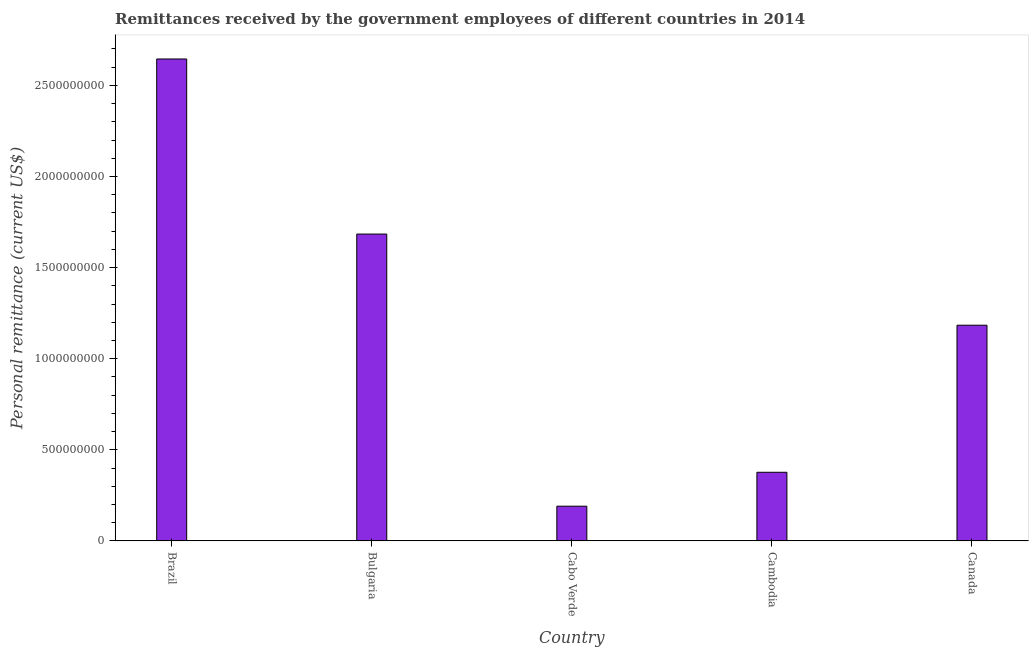Does the graph contain grids?
Your answer should be compact. No. What is the title of the graph?
Give a very brief answer. Remittances received by the government employees of different countries in 2014. What is the label or title of the X-axis?
Offer a very short reply. Country. What is the label or title of the Y-axis?
Your answer should be compact. Personal remittance (current US$). What is the personal remittances in Bulgaria?
Keep it short and to the point. 1.68e+09. Across all countries, what is the maximum personal remittances?
Provide a succinct answer. 2.65e+09. Across all countries, what is the minimum personal remittances?
Provide a succinct answer. 1.91e+08. In which country was the personal remittances maximum?
Your response must be concise. Brazil. In which country was the personal remittances minimum?
Provide a succinct answer. Cabo Verde. What is the sum of the personal remittances?
Make the answer very short. 6.08e+09. What is the difference between the personal remittances in Brazil and Bulgaria?
Offer a very short reply. 9.61e+08. What is the average personal remittances per country?
Provide a short and direct response. 1.22e+09. What is the median personal remittances?
Offer a very short reply. 1.18e+09. In how many countries, is the personal remittances greater than 2200000000 US$?
Offer a terse response. 1. What is the ratio of the personal remittances in Cabo Verde to that in Canada?
Your answer should be very brief. 0.16. Is the personal remittances in Bulgaria less than that in Cambodia?
Provide a succinct answer. No. What is the difference between the highest and the second highest personal remittances?
Your response must be concise. 9.61e+08. Is the sum of the personal remittances in Brazil and Cabo Verde greater than the maximum personal remittances across all countries?
Your answer should be compact. Yes. What is the difference between the highest and the lowest personal remittances?
Your response must be concise. 2.45e+09. Are all the bars in the graph horizontal?
Provide a short and direct response. No. What is the difference between two consecutive major ticks on the Y-axis?
Your answer should be very brief. 5.00e+08. What is the Personal remittance (current US$) of Brazil?
Offer a very short reply. 2.65e+09. What is the Personal remittance (current US$) of Bulgaria?
Your answer should be compact. 1.68e+09. What is the Personal remittance (current US$) of Cabo Verde?
Your response must be concise. 1.91e+08. What is the Personal remittance (current US$) in Cambodia?
Ensure brevity in your answer.  3.77e+08. What is the Personal remittance (current US$) in Canada?
Your answer should be very brief. 1.18e+09. What is the difference between the Personal remittance (current US$) in Brazil and Bulgaria?
Offer a terse response. 9.61e+08. What is the difference between the Personal remittance (current US$) in Brazil and Cabo Verde?
Your answer should be compact. 2.45e+09. What is the difference between the Personal remittance (current US$) in Brazil and Cambodia?
Your answer should be compact. 2.27e+09. What is the difference between the Personal remittance (current US$) in Brazil and Canada?
Your answer should be compact. 1.46e+09. What is the difference between the Personal remittance (current US$) in Bulgaria and Cabo Verde?
Offer a terse response. 1.49e+09. What is the difference between the Personal remittance (current US$) in Bulgaria and Cambodia?
Offer a terse response. 1.31e+09. What is the difference between the Personal remittance (current US$) in Bulgaria and Canada?
Provide a short and direct response. 5.00e+08. What is the difference between the Personal remittance (current US$) in Cabo Verde and Cambodia?
Ensure brevity in your answer.  -1.86e+08. What is the difference between the Personal remittance (current US$) in Cabo Verde and Canada?
Your answer should be very brief. -9.93e+08. What is the difference between the Personal remittance (current US$) in Cambodia and Canada?
Offer a very short reply. -8.07e+08. What is the ratio of the Personal remittance (current US$) in Brazil to that in Bulgaria?
Your response must be concise. 1.57. What is the ratio of the Personal remittance (current US$) in Brazil to that in Cabo Verde?
Your answer should be compact. 13.88. What is the ratio of the Personal remittance (current US$) in Brazil to that in Cambodia?
Ensure brevity in your answer.  7.02. What is the ratio of the Personal remittance (current US$) in Brazil to that in Canada?
Your response must be concise. 2.23. What is the ratio of the Personal remittance (current US$) in Bulgaria to that in Cabo Verde?
Offer a terse response. 8.83. What is the ratio of the Personal remittance (current US$) in Bulgaria to that in Cambodia?
Provide a succinct answer. 4.47. What is the ratio of the Personal remittance (current US$) in Bulgaria to that in Canada?
Ensure brevity in your answer.  1.42. What is the ratio of the Personal remittance (current US$) in Cabo Verde to that in Cambodia?
Provide a succinct answer. 0.51. What is the ratio of the Personal remittance (current US$) in Cabo Verde to that in Canada?
Your answer should be very brief. 0.16. What is the ratio of the Personal remittance (current US$) in Cambodia to that in Canada?
Offer a terse response. 0.32. 